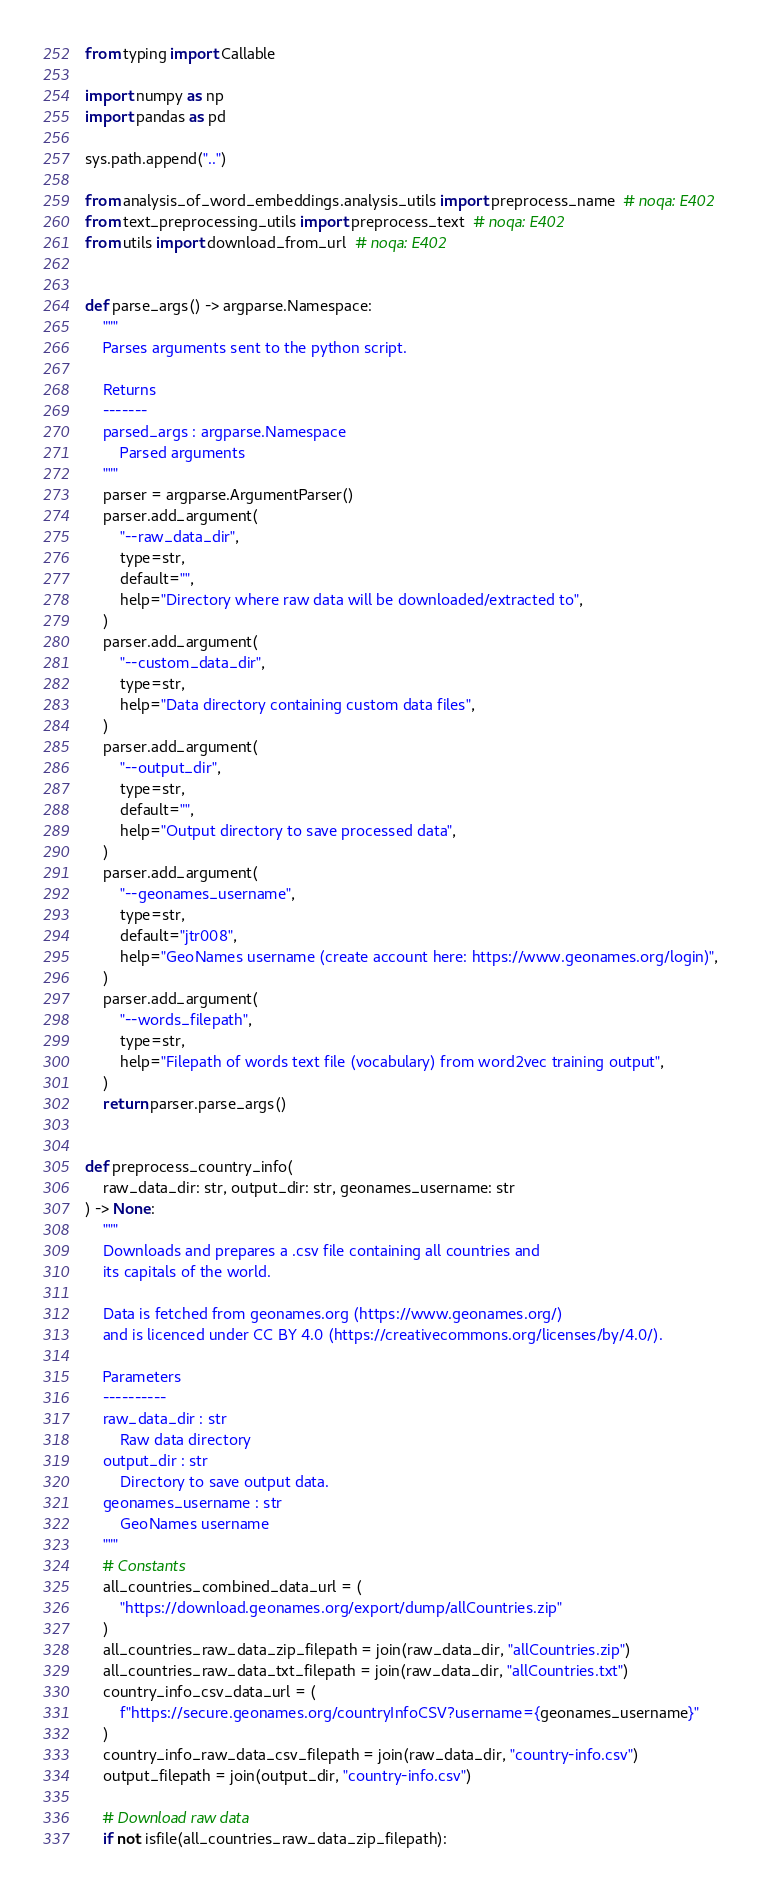Convert code to text. <code><loc_0><loc_0><loc_500><loc_500><_Python_>from typing import Callable

import numpy as np
import pandas as pd

sys.path.append("..")

from analysis_of_word_embeddings.analysis_utils import preprocess_name  # noqa: E402
from text_preprocessing_utils import preprocess_text  # noqa: E402
from utils import download_from_url  # noqa: E402


def parse_args() -> argparse.Namespace:
    """
    Parses arguments sent to the python script.

    Returns
    -------
    parsed_args : argparse.Namespace
        Parsed arguments
    """
    parser = argparse.ArgumentParser()
    parser.add_argument(
        "--raw_data_dir",
        type=str,
        default="",
        help="Directory where raw data will be downloaded/extracted to",
    )
    parser.add_argument(
        "--custom_data_dir",
        type=str,
        help="Data directory containing custom data files",
    )
    parser.add_argument(
        "--output_dir",
        type=str,
        default="",
        help="Output directory to save processed data",
    )
    parser.add_argument(
        "--geonames_username",
        type=str,
        default="jtr008",
        help="GeoNames username (create account here: https://www.geonames.org/login)",
    )
    parser.add_argument(
        "--words_filepath",
        type=str,
        help="Filepath of words text file (vocabulary) from word2vec training output",
    )
    return parser.parse_args()


def preprocess_country_info(
    raw_data_dir: str, output_dir: str, geonames_username: str
) -> None:
    """
    Downloads and prepares a .csv file containing all countries and
    its capitals of the world.

    Data is fetched from geonames.org (https://www.geonames.org/)
    and is licenced under CC BY 4.0 (https://creativecommons.org/licenses/by/4.0/).

    Parameters
    ----------
    raw_data_dir : str
        Raw data directory
    output_dir : str
        Directory to save output data.
    geonames_username : str
        GeoNames username
    """
    # Constants
    all_countries_combined_data_url = (
        "https://download.geonames.org/export/dump/allCountries.zip"
    )
    all_countries_raw_data_zip_filepath = join(raw_data_dir, "allCountries.zip")
    all_countries_raw_data_txt_filepath = join(raw_data_dir, "allCountries.txt")
    country_info_csv_data_url = (
        f"https://secure.geonames.org/countryInfoCSV?username={geonames_username}"
    )
    country_info_raw_data_csv_filepath = join(raw_data_dir, "country-info.csv")
    output_filepath = join(output_dir, "country-info.csv")

    # Download raw data
    if not isfile(all_countries_raw_data_zip_filepath):</code> 